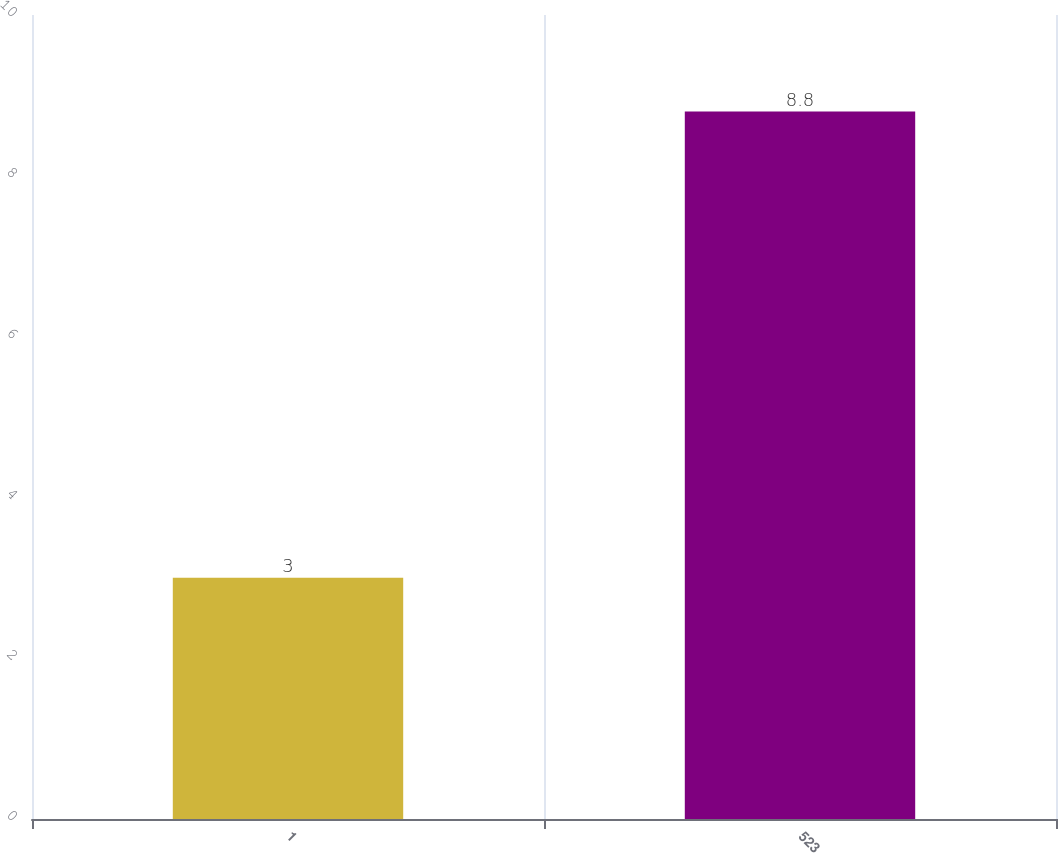<chart> <loc_0><loc_0><loc_500><loc_500><bar_chart><fcel>1<fcel>523<nl><fcel>3<fcel>8.8<nl></chart> 